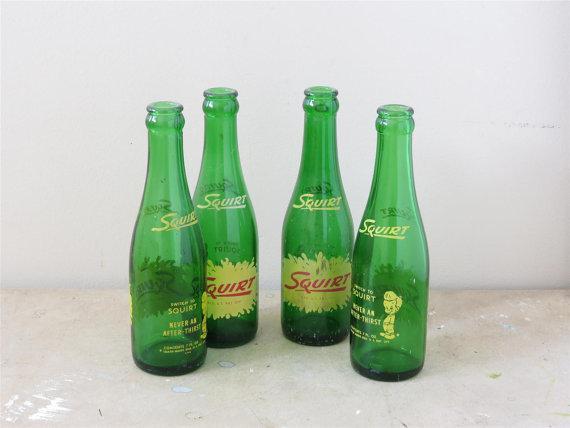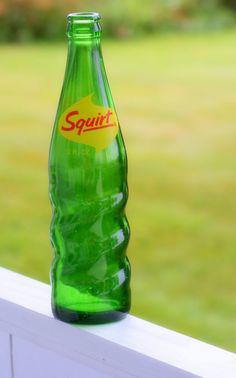The first image is the image on the left, the second image is the image on the right. Examine the images to the left and right. Is the description "Each image contains one green bottle, and at least one of the bottles pictured has diagonal ribs around its lower half." accurate? Answer yes or no. No. The first image is the image on the left, the second image is the image on the right. Considering the images on both sides, is "The left image contains exactly four glass bottles." valid? Answer yes or no. Yes. 